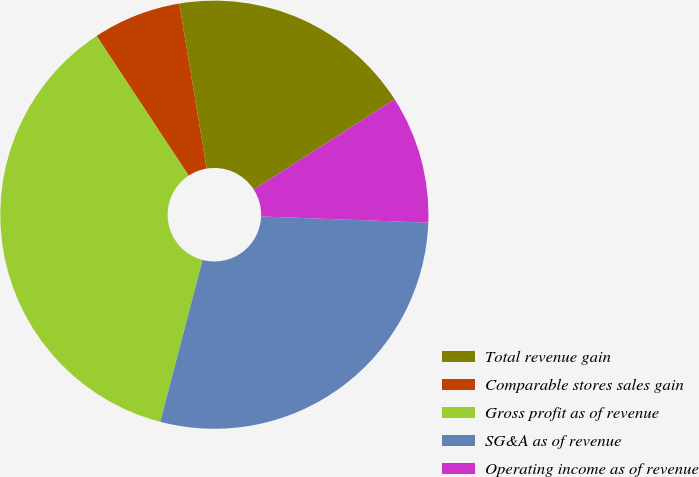Convert chart. <chart><loc_0><loc_0><loc_500><loc_500><pie_chart><fcel>Total revenue gain<fcel>Comparable stores sales gain<fcel>Gross profit as of revenue<fcel>SG&A as of revenue<fcel>Operating income as of revenue<nl><fcel>18.56%<fcel>6.65%<fcel>36.66%<fcel>28.47%<fcel>9.65%<nl></chart> 